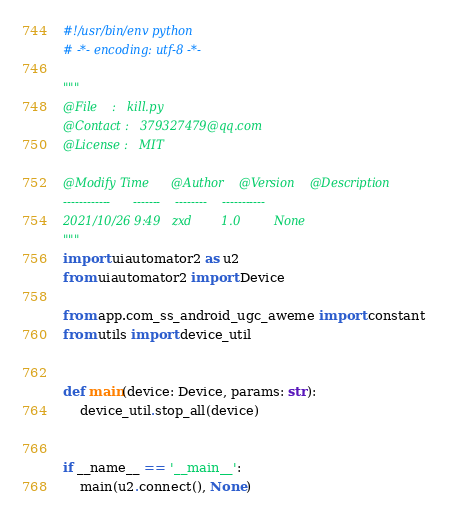<code> <loc_0><loc_0><loc_500><loc_500><_Python_>#!/usr/bin/env python
# -*- encoding: utf-8 -*-

"""
@File    :   kill.py
@Contact :   379327479@qq.com
@License :   MIT

@Modify Time      @Author    @Version    @Description
------------      -------    --------    -----------
2021/10/26 9:49   zxd        1.0         None
"""
import uiautomator2 as u2
from uiautomator2 import Device

from app.com_ss_android_ugc_aweme import constant
from utils import device_util


def main(device: Device, params: str):
    device_util.stop_all(device)


if __name__ == '__main__':
    main(u2.connect(), None)
</code> 